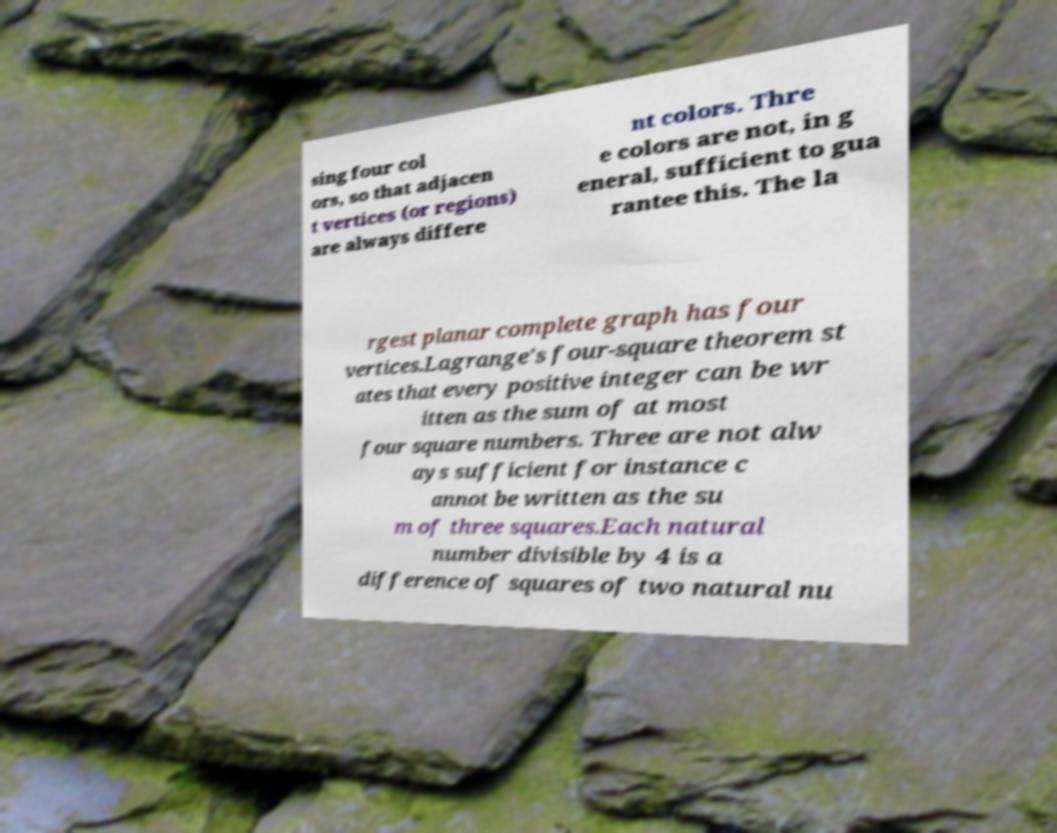Could you assist in decoding the text presented in this image and type it out clearly? sing four col ors, so that adjacen t vertices (or regions) are always differe nt colors. Thre e colors are not, in g eneral, sufficient to gua rantee this. The la rgest planar complete graph has four vertices.Lagrange's four-square theorem st ates that every positive integer can be wr itten as the sum of at most four square numbers. Three are not alw ays sufficient for instance c annot be written as the su m of three squares.Each natural number divisible by 4 is a difference of squares of two natural nu 